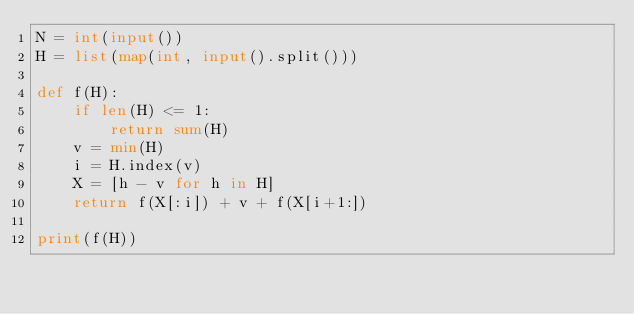Convert code to text. <code><loc_0><loc_0><loc_500><loc_500><_Python_>N = int(input())
H = list(map(int, input().split()))

def f(H):
    if len(H) <= 1:
        return sum(H)
    v = min(H)
    i = H.index(v)
    X = [h - v for h in H]
    return f(X[:i]) + v + f(X[i+1:])

print(f(H))
</code> 